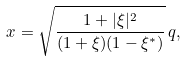<formula> <loc_0><loc_0><loc_500><loc_500>x = \sqrt { \frac { 1 + | \xi | ^ { 2 } } { ( 1 + \xi ) ( 1 - \xi ^ { * } ) } } \, q ,</formula> 